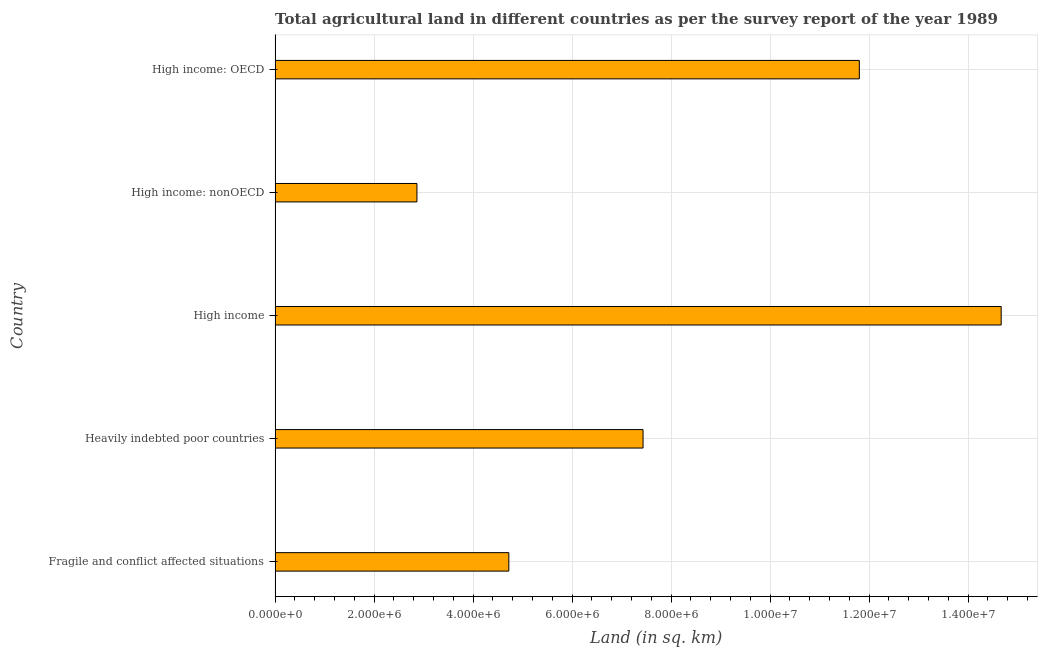Does the graph contain any zero values?
Your answer should be very brief. No. What is the title of the graph?
Offer a very short reply. Total agricultural land in different countries as per the survey report of the year 1989. What is the label or title of the X-axis?
Offer a very short reply. Land (in sq. km). What is the agricultural land in High income?
Offer a very short reply. 1.47e+07. Across all countries, what is the maximum agricultural land?
Provide a short and direct response. 1.47e+07. Across all countries, what is the minimum agricultural land?
Your answer should be very brief. 2.87e+06. In which country was the agricultural land minimum?
Your response must be concise. High income: nonOECD. What is the sum of the agricultural land?
Provide a succinct answer. 4.15e+07. What is the difference between the agricultural land in Fragile and conflict affected situations and High income: nonOECD?
Provide a succinct answer. 1.86e+06. What is the average agricultural land per country?
Offer a very short reply. 8.30e+06. What is the median agricultural land?
Ensure brevity in your answer.  7.43e+06. In how many countries, is the agricultural land greater than 7200000 sq. km?
Make the answer very short. 3. What is the ratio of the agricultural land in Heavily indebted poor countries to that in High income: nonOECD?
Provide a succinct answer. 2.59. Is the difference between the agricultural land in Heavily indebted poor countries and High income: nonOECD greater than the difference between any two countries?
Offer a terse response. No. What is the difference between the highest and the second highest agricultural land?
Provide a succinct answer. 2.87e+06. Is the sum of the agricultural land in High income: OECD and High income: nonOECD greater than the maximum agricultural land across all countries?
Make the answer very short. No. What is the difference between the highest and the lowest agricultural land?
Your answer should be very brief. 1.18e+07. In how many countries, is the agricultural land greater than the average agricultural land taken over all countries?
Provide a short and direct response. 2. Are all the bars in the graph horizontal?
Offer a terse response. Yes. What is the difference between two consecutive major ticks on the X-axis?
Give a very brief answer. 2.00e+06. Are the values on the major ticks of X-axis written in scientific E-notation?
Your answer should be compact. Yes. What is the Land (in sq. km) of Fragile and conflict affected situations?
Make the answer very short. 4.72e+06. What is the Land (in sq. km) of Heavily indebted poor countries?
Keep it short and to the point. 7.43e+06. What is the Land (in sq. km) of High income?
Make the answer very short. 1.47e+07. What is the Land (in sq. km) in High income: nonOECD?
Your answer should be compact. 2.87e+06. What is the Land (in sq. km) of High income: OECD?
Provide a short and direct response. 1.18e+07. What is the difference between the Land (in sq. km) in Fragile and conflict affected situations and Heavily indebted poor countries?
Your response must be concise. -2.71e+06. What is the difference between the Land (in sq. km) in Fragile and conflict affected situations and High income?
Ensure brevity in your answer.  -9.95e+06. What is the difference between the Land (in sq. km) in Fragile and conflict affected situations and High income: nonOECD?
Make the answer very short. 1.86e+06. What is the difference between the Land (in sq. km) in Fragile and conflict affected situations and High income: OECD?
Give a very brief answer. -7.08e+06. What is the difference between the Land (in sq. km) in Heavily indebted poor countries and High income?
Provide a short and direct response. -7.23e+06. What is the difference between the Land (in sq. km) in Heavily indebted poor countries and High income: nonOECD?
Your answer should be very brief. 4.57e+06. What is the difference between the Land (in sq. km) in Heavily indebted poor countries and High income: OECD?
Offer a very short reply. -4.37e+06. What is the difference between the Land (in sq. km) in High income and High income: nonOECD?
Your answer should be compact. 1.18e+07. What is the difference between the Land (in sq. km) in High income and High income: OECD?
Ensure brevity in your answer.  2.87e+06. What is the difference between the Land (in sq. km) in High income: nonOECD and High income: OECD?
Give a very brief answer. -8.94e+06. What is the ratio of the Land (in sq. km) in Fragile and conflict affected situations to that in Heavily indebted poor countries?
Give a very brief answer. 0.64. What is the ratio of the Land (in sq. km) in Fragile and conflict affected situations to that in High income?
Provide a short and direct response. 0.32. What is the ratio of the Land (in sq. km) in Fragile and conflict affected situations to that in High income: nonOECD?
Provide a short and direct response. 1.65. What is the ratio of the Land (in sq. km) in Heavily indebted poor countries to that in High income?
Your response must be concise. 0.51. What is the ratio of the Land (in sq. km) in Heavily indebted poor countries to that in High income: nonOECD?
Your answer should be very brief. 2.59. What is the ratio of the Land (in sq. km) in Heavily indebted poor countries to that in High income: OECD?
Make the answer very short. 0.63. What is the ratio of the Land (in sq. km) in High income to that in High income: nonOECD?
Keep it short and to the point. 5.12. What is the ratio of the Land (in sq. km) in High income to that in High income: OECD?
Offer a very short reply. 1.24. What is the ratio of the Land (in sq. km) in High income: nonOECD to that in High income: OECD?
Provide a short and direct response. 0.24. 